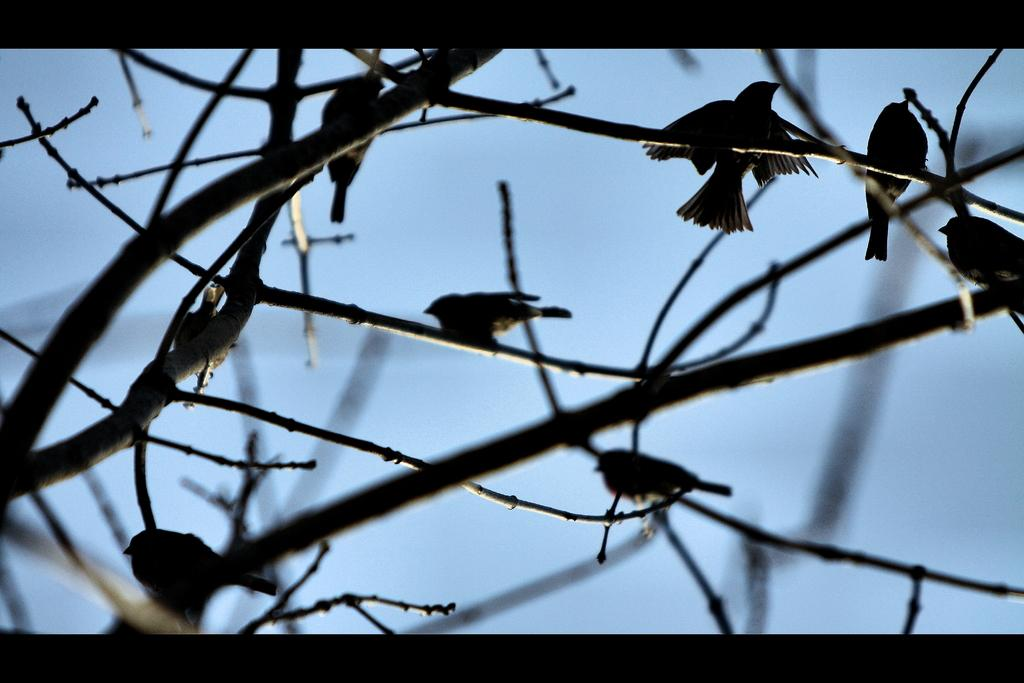What type of animals can be seen in the image? Birds can be seen in the image. Where are the birds located? The birds are on tree stems. What type of pet is visible in the image? There is no pet visible in the image; it features birds on tree stems. What phase of the moon can be seen in the image? There is no moon visible in the image; it only shows birds on tree stems. 